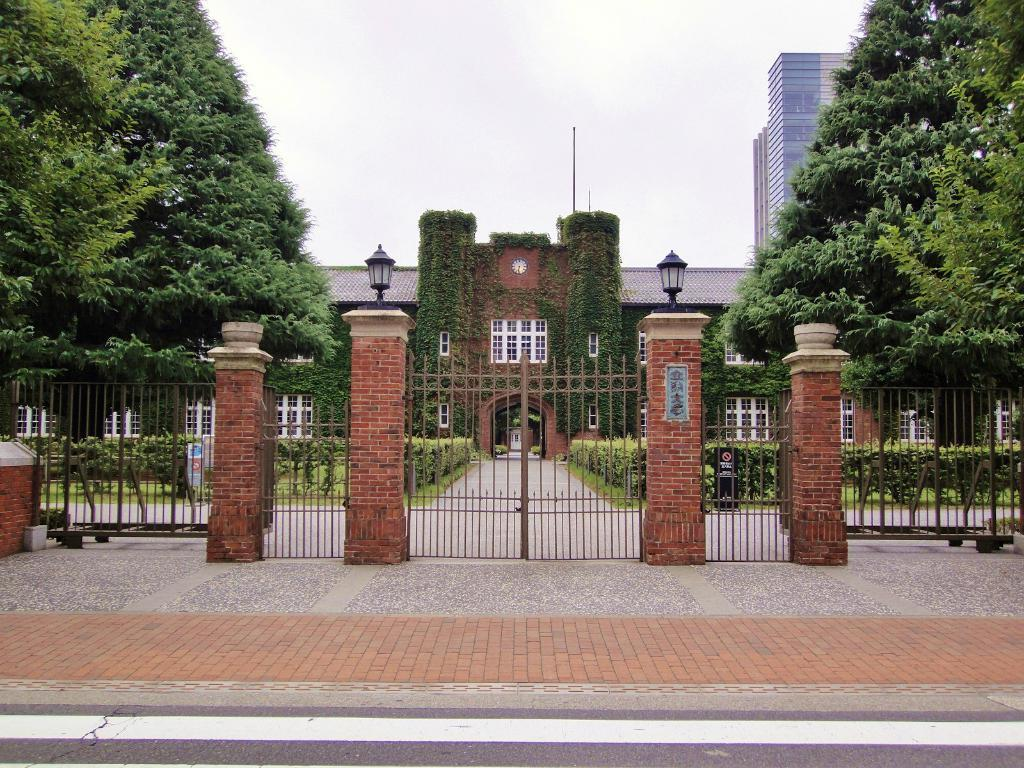What type of structure is visible in the image? There is a building in the image. What decorative elements are present on the building? There are lanterns on the pillars of the building. What is the entrance to the building like? There is a gate in the image. What can be seen in the background of the image? There are trees and other buildings in the background of the image. What type of shade does the building provide in the image? The image does not provide information about the shade provided by the building. 